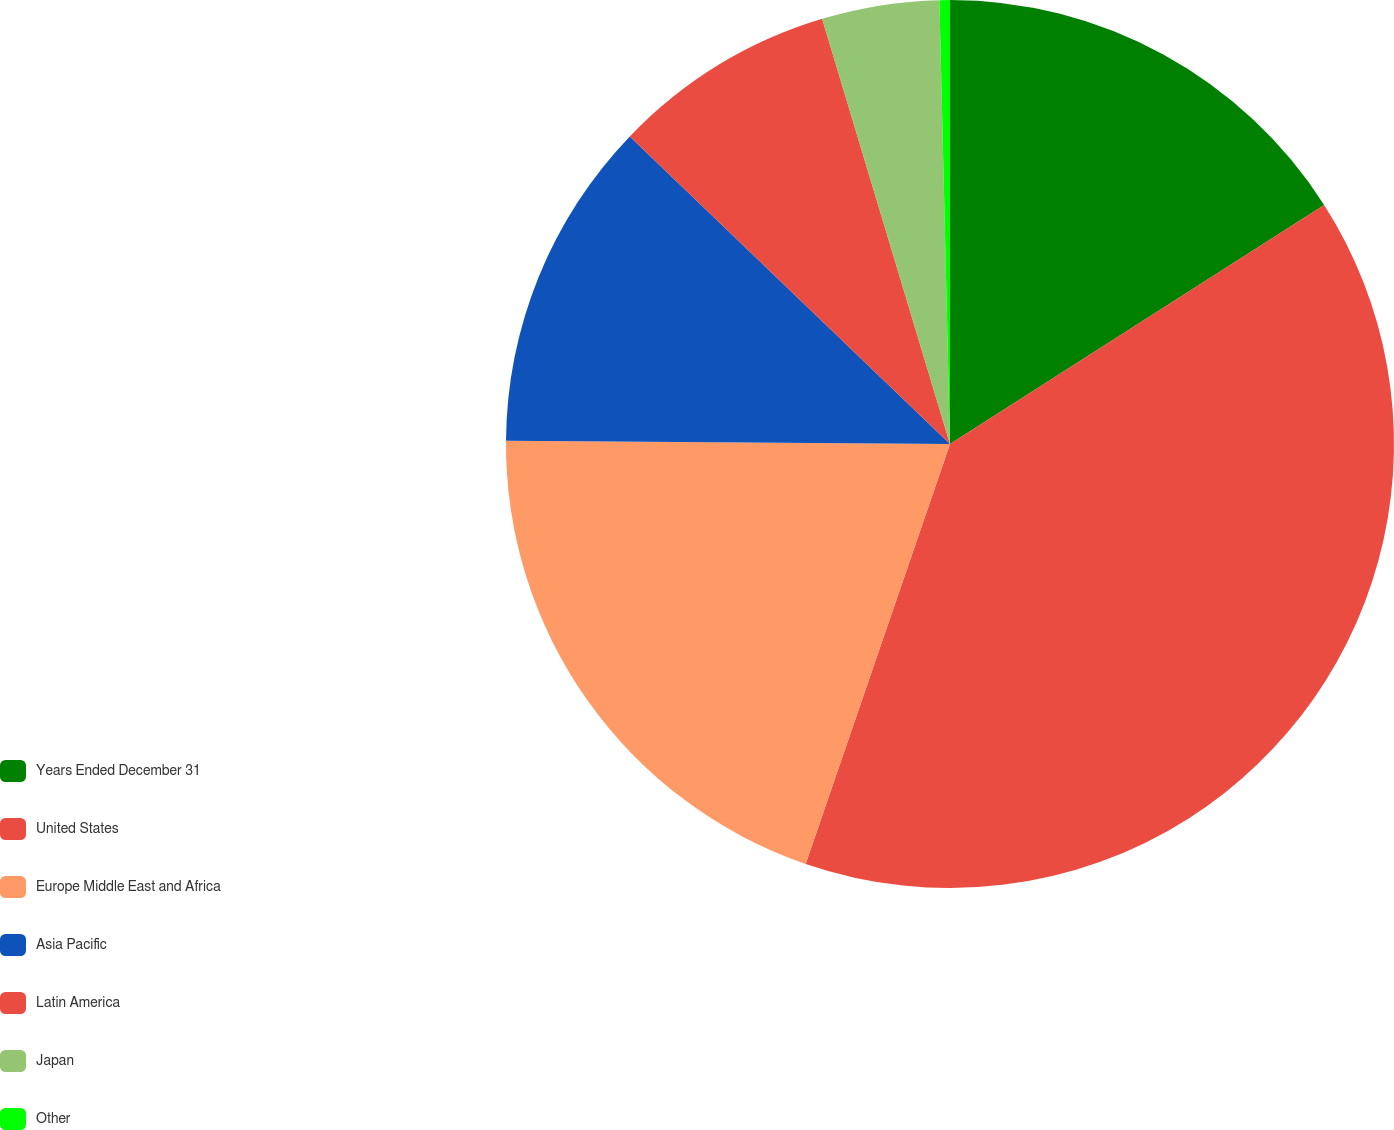<chart> <loc_0><loc_0><loc_500><loc_500><pie_chart><fcel>Years Ended December 31<fcel>United States<fcel>Europe Middle East and Africa<fcel>Asia Pacific<fcel>Latin America<fcel>Japan<fcel>Other<nl><fcel>15.95%<fcel>39.32%<fcel>19.85%<fcel>12.06%<fcel>8.17%<fcel>4.27%<fcel>0.38%<nl></chart> 